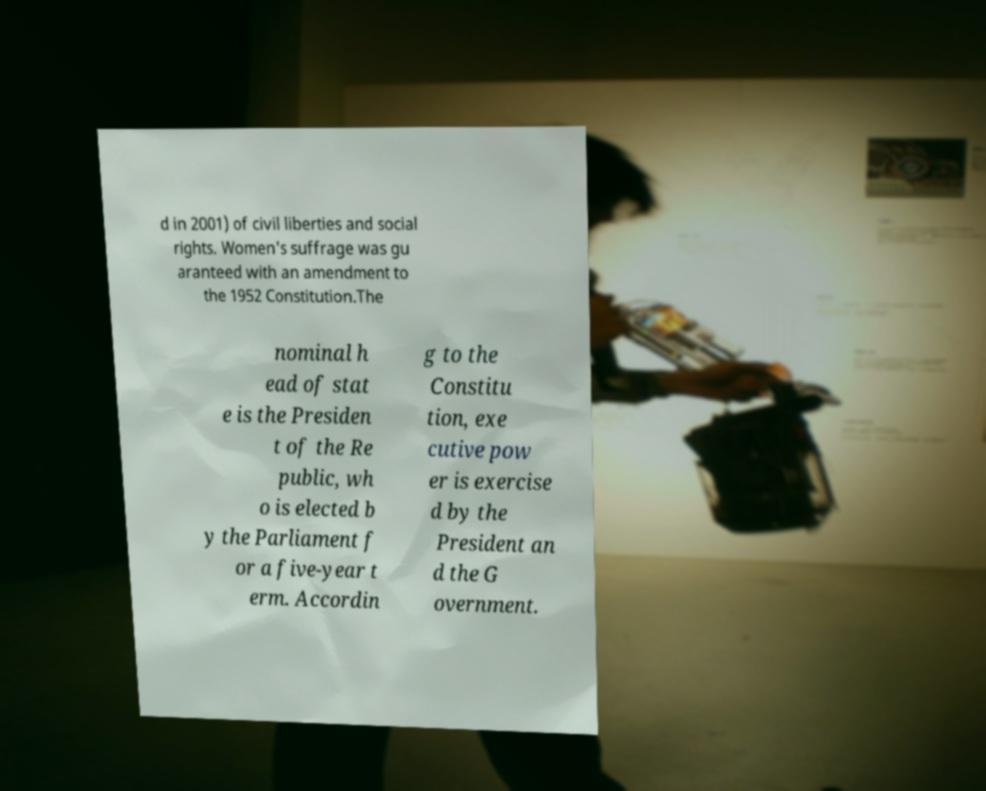What messages or text are displayed in this image? I need them in a readable, typed format. d in 2001) of civil liberties and social rights. Women's suffrage was gu aranteed with an amendment to the 1952 Constitution.The nominal h ead of stat e is the Presiden t of the Re public, wh o is elected b y the Parliament f or a five-year t erm. Accordin g to the Constitu tion, exe cutive pow er is exercise d by the President an d the G overnment. 